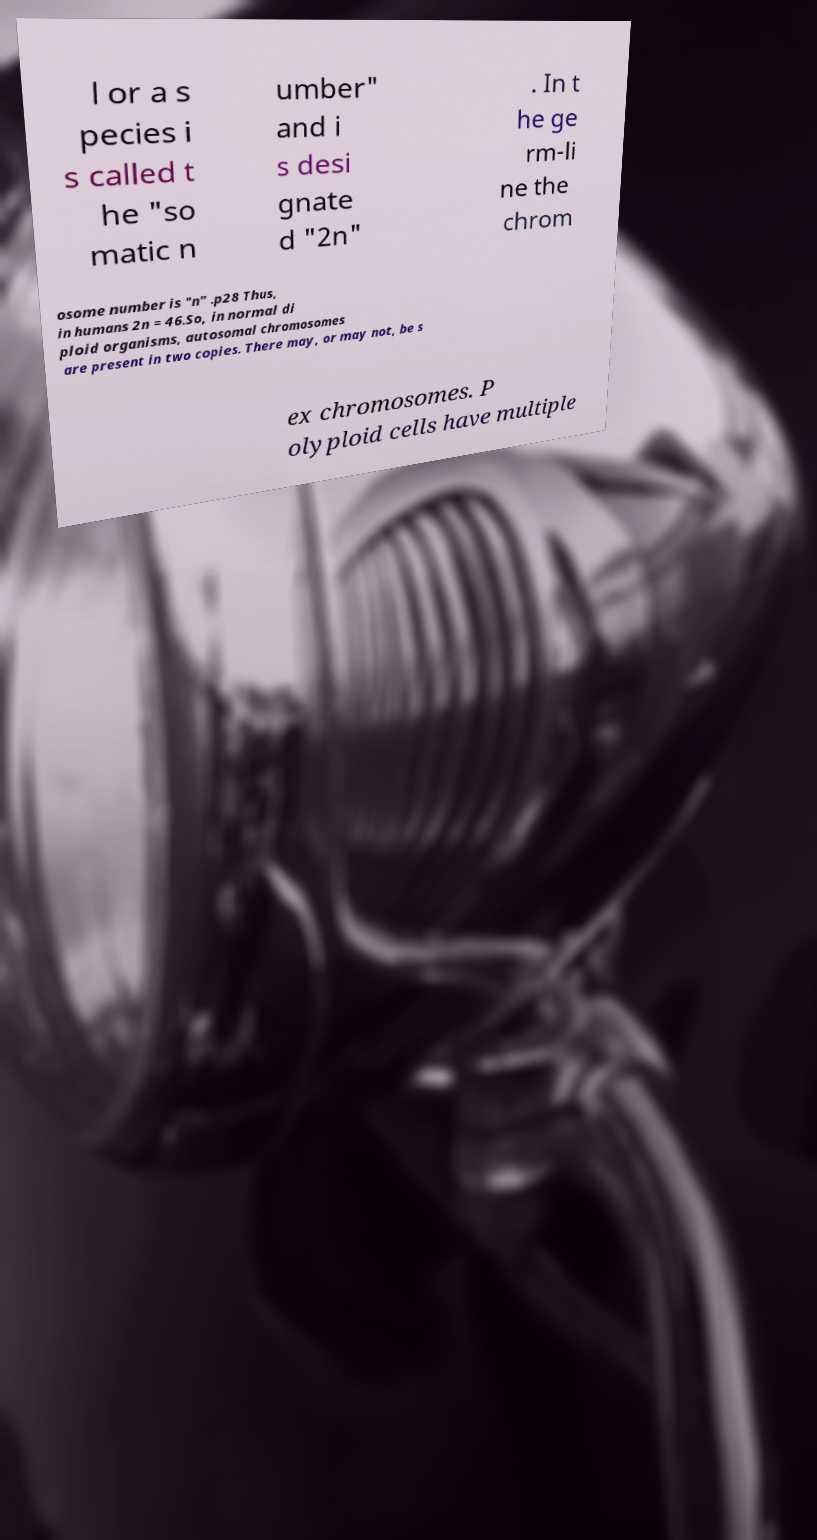Could you assist in decoding the text presented in this image and type it out clearly? l or a s pecies i s called t he "so matic n umber" and i s desi gnate d "2n" . In t he ge rm-li ne the chrom osome number is "n" .p28 Thus, in humans 2n = 46.So, in normal di ploid organisms, autosomal chromosomes are present in two copies. There may, or may not, be s ex chromosomes. P olyploid cells have multiple 